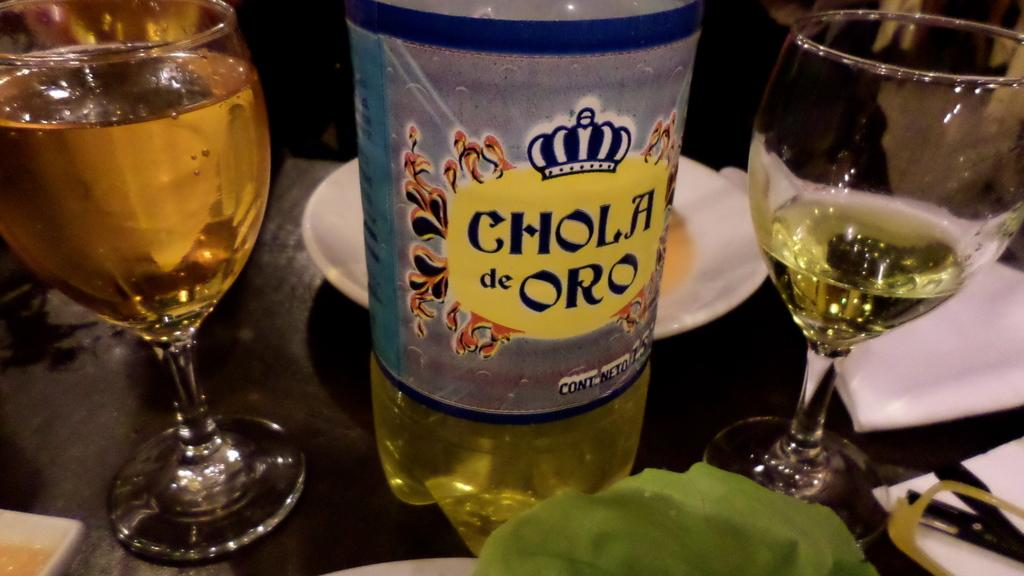How many wine glasses are visible in the image? There are two wine glasses in the image. What else is present on the table with the wine glasses? There is a bottle in the image. Where are the wine glasses and the bottle located? The wine glasses and the bottle are on a table. What type of organization is represented by the brick in the image? There is no brick present in the image. What kind of meat is being served with the wine in the image? There is no meat present in the image; only wine glasses and a bottle are visible. 